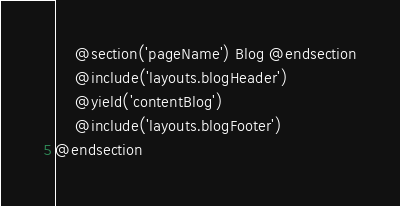Convert code to text. <code><loc_0><loc_0><loc_500><loc_500><_PHP_>    @section('pageName') Blog @endsection
    @include('layouts.blogHeader')
    @yield('contentBlog')
    @include('layouts.blogFooter')
@endsection
</code> 